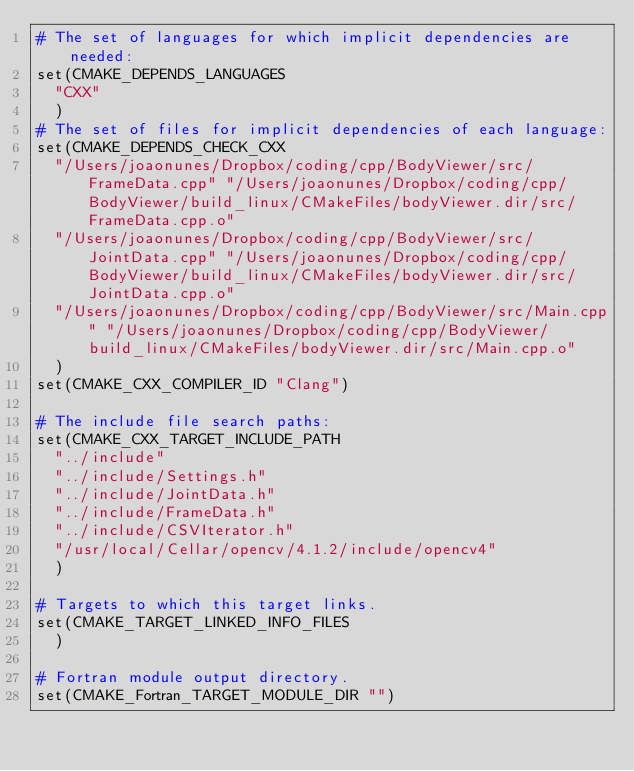Convert code to text. <code><loc_0><loc_0><loc_500><loc_500><_CMake_># The set of languages for which implicit dependencies are needed:
set(CMAKE_DEPENDS_LANGUAGES
  "CXX"
  )
# The set of files for implicit dependencies of each language:
set(CMAKE_DEPENDS_CHECK_CXX
  "/Users/joaonunes/Dropbox/coding/cpp/BodyViewer/src/FrameData.cpp" "/Users/joaonunes/Dropbox/coding/cpp/BodyViewer/build_linux/CMakeFiles/bodyViewer.dir/src/FrameData.cpp.o"
  "/Users/joaonunes/Dropbox/coding/cpp/BodyViewer/src/JointData.cpp" "/Users/joaonunes/Dropbox/coding/cpp/BodyViewer/build_linux/CMakeFiles/bodyViewer.dir/src/JointData.cpp.o"
  "/Users/joaonunes/Dropbox/coding/cpp/BodyViewer/src/Main.cpp" "/Users/joaonunes/Dropbox/coding/cpp/BodyViewer/build_linux/CMakeFiles/bodyViewer.dir/src/Main.cpp.o"
  )
set(CMAKE_CXX_COMPILER_ID "Clang")

# The include file search paths:
set(CMAKE_CXX_TARGET_INCLUDE_PATH
  "../include"
  "../include/Settings.h"
  "../include/JointData.h"
  "../include/FrameData.h"
  "../include/CSVIterator.h"
  "/usr/local/Cellar/opencv/4.1.2/include/opencv4"
  )

# Targets to which this target links.
set(CMAKE_TARGET_LINKED_INFO_FILES
  )

# Fortran module output directory.
set(CMAKE_Fortran_TARGET_MODULE_DIR "")
</code> 